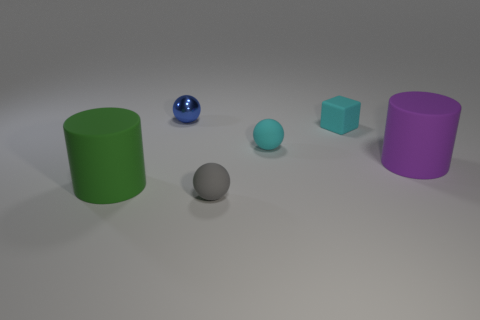Do the cylinder that is right of the tiny gray sphere and the large cylinder on the left side of the tiny blue ball have the same material?
Offer a very short reply. Yes. Are there any big cylinders that are on the right side of the big object on the right side of the small blue ball?
Give a very brief answer. No. There is a large cylinder that is made of the same material as the large green object; what color is it?
Make the answer very short. Purple. Are there more tiny blue metal things than cylinders?
Your response must be concise. No. How many things are either rubber objects on the right side of the small metal ball or big blue things?
Give a very brief answer. 4. Are there any brown rubber spheres that have the same size as the cyan rubber block?
Your response must be concise. No. Is the number of purple matte cylinders less than the number of yellow rubber cylinders?
Provide a succinct answer. No. How many cubes are either cyan things or blue rubber things?
Provide a succinct answer. 1. What number of small matte things have the same color as the matte block?
Your response must be concise. 1. What size is the matte object that is on the left side of the small cube and on the right side of the small gray rubber object?
Offer a very short reply. Small. 